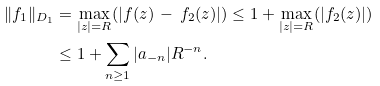<formula> <loc_0><loc_0><loc_500><loc_500>\| f _ { 1 } \| _ { D _ { 1 } } & = \max _ { | z | = R } ( | f ( z ) \, - \, f _ { 2 } ( z ) | ) \leq 1 + \max _ { | z | = R } ( | f _ { 2 } ( z ) | ) \\ & \leq 1 + \sum _ { n \geq 1 } | a _ { - n } | R ^ { - n } .</formula> 